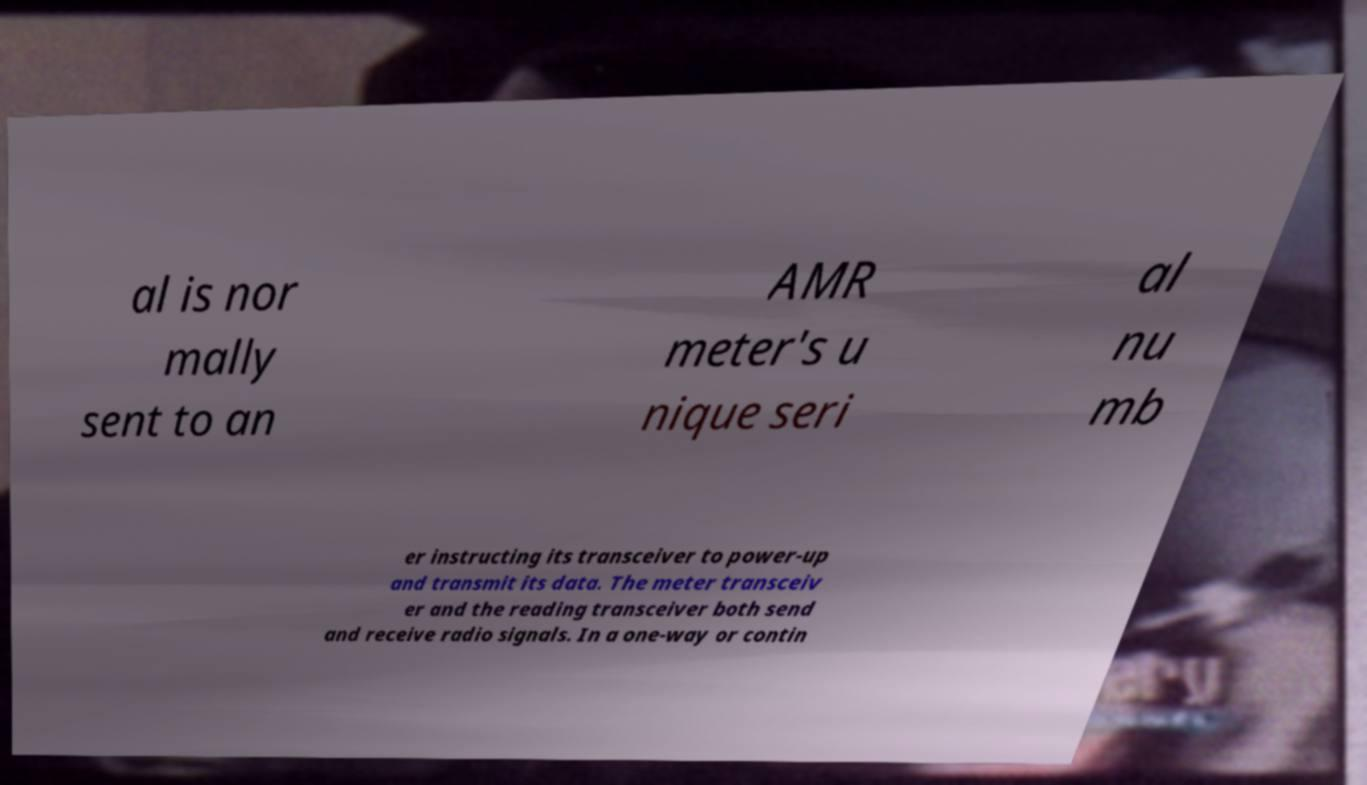Can you accurately transcribe the text from the provided image for me? al is nor mally sent to an AMR meter's u nique seri al nu mb er instructing its transceiver to power-up and transmit its data. The meter transceiv er and the reading transceiver both send and receive radio signals. In a one-way or contin 